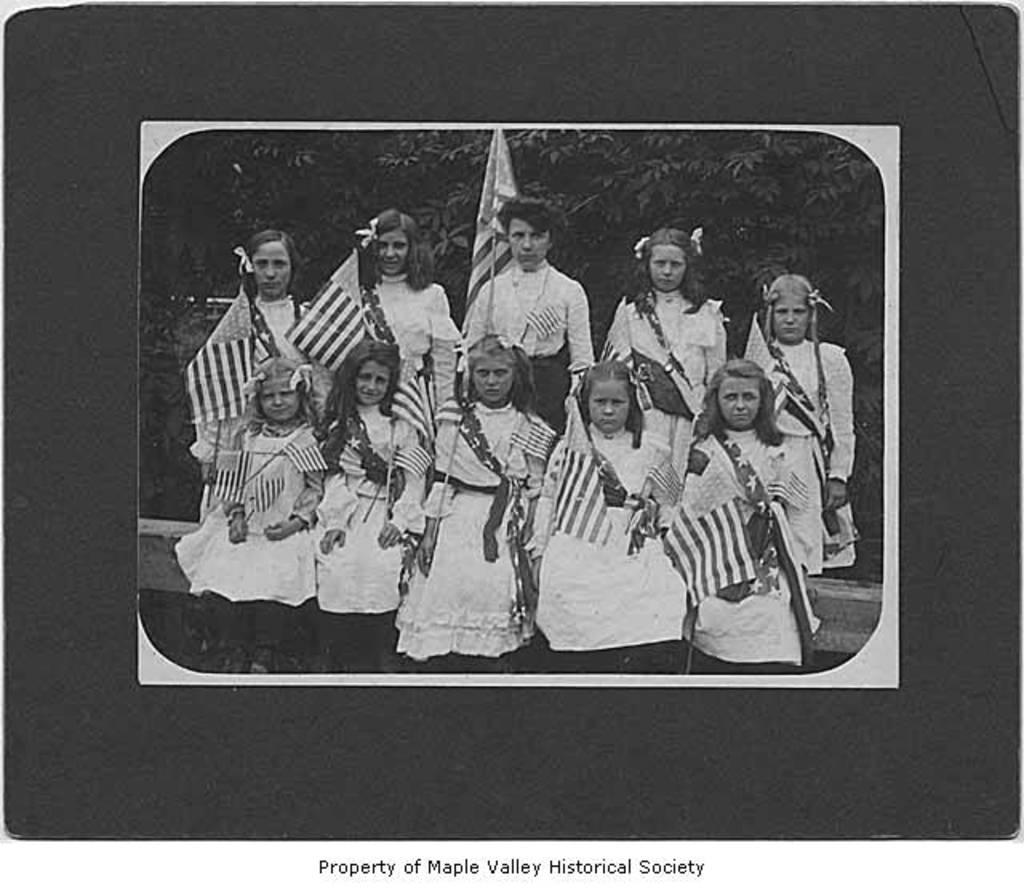What is the color scheme of the image? The image is black and white. How many girls are present in the image? There are many girls in the image. What are the girls doing in the image? The girls are sitting and standing in the image. What are the girls holding in the image? The girls are holding flags in the image. What can be seen in the background of the image? There are trees visible in the background of the image. What type of quince is being used as a prop in the image? There is: There is no quince present in the image; it features many girls holding flags and trees in the background. How many ants can be seen crawling on the girls in the image? There are no ants visible in the image; it features many girls holding flags and trees in the background. 